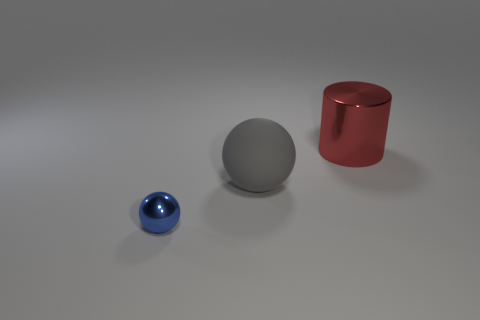There is a metal thing behind the metal object that is on the left side of the big cylinder; how many tiny blue balls are to the right of it? 0 